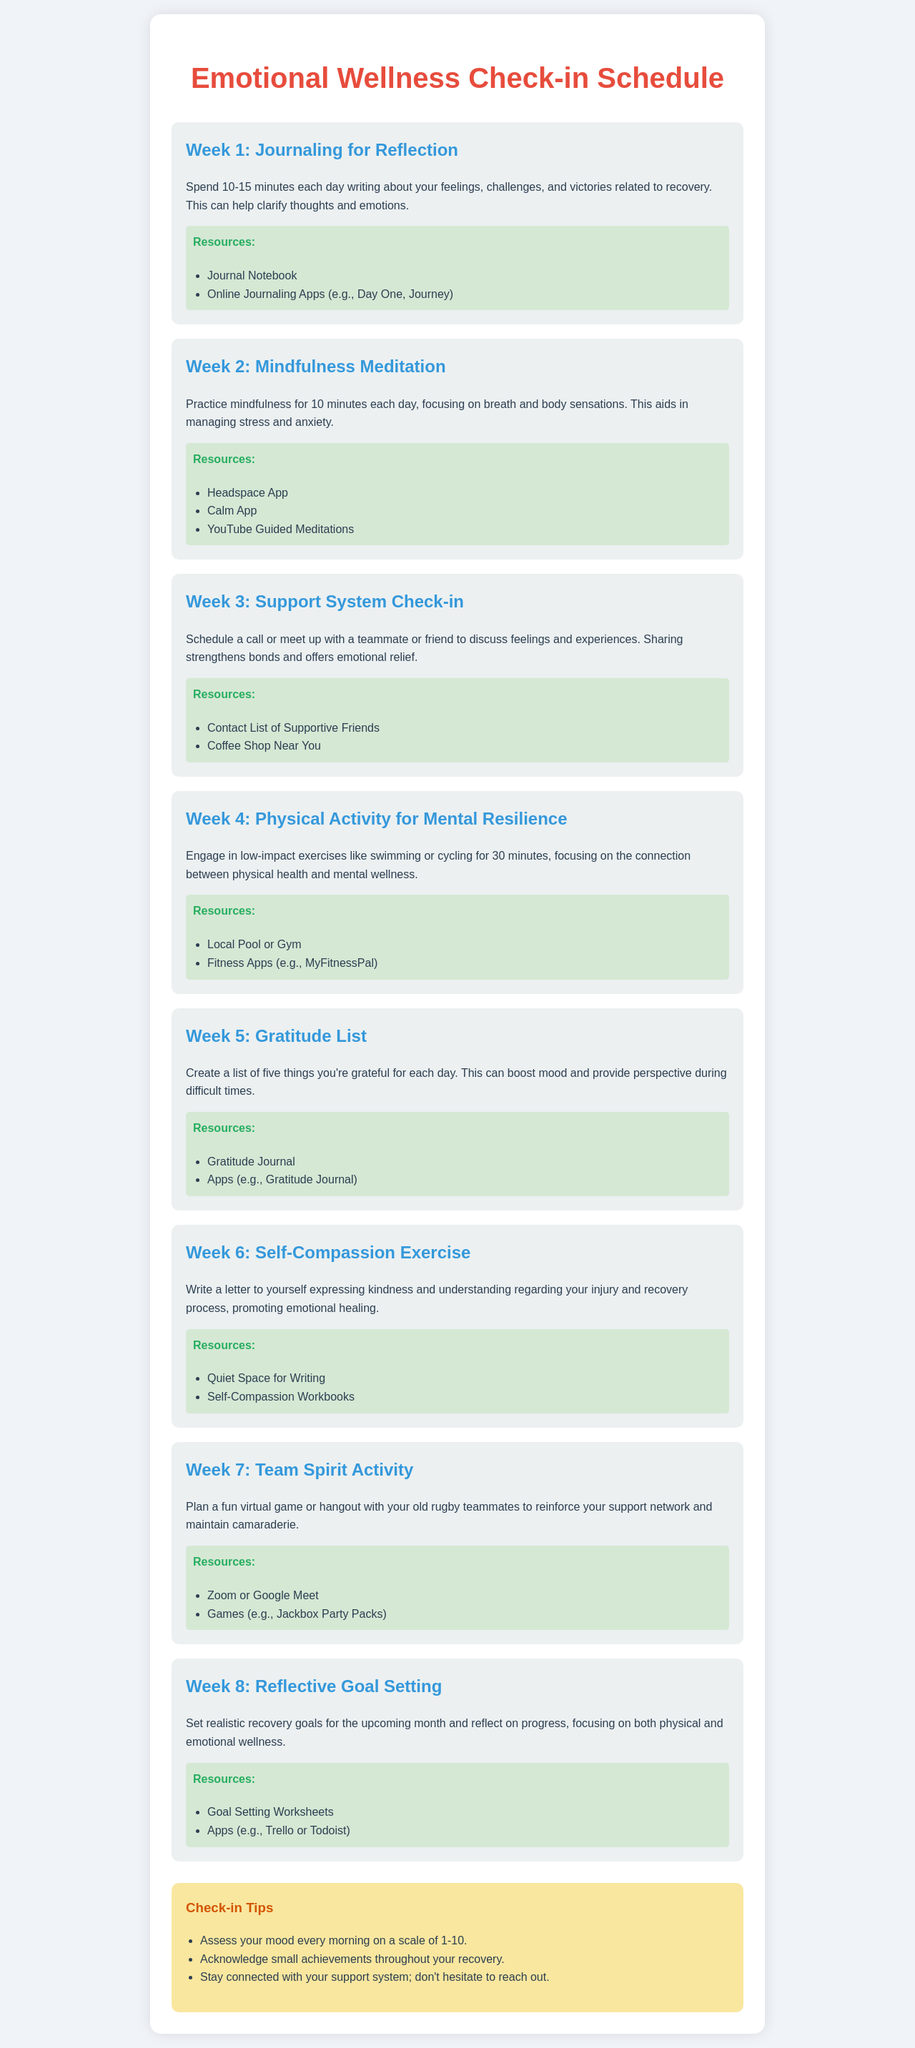what is the title of the document? The title can be found in the header of the document, which is "Emotional Wellness Check-in Schedule."
Answer: Emotional Wellness Check-in Schedule how many weeks are outlined in the schedule? The document lists a total of eight weeks for emotional wellness activities.
Answer: 8 what is the focus of Week 3's activity? Week 3's activity centers around having a support system check-in, allowing for sharing feelings and experiences.
Answer: Support System Check-in name one resource listed for Week 5. The document provides various resources for each week, such as "Gratitude Journal" for Week 5.
Answer: Gratitude Journal what type of exercise is suggested in Week 4? Week 4 recommends engaging in low-impact exercises to boost mental resilience, specifying activities like swimming or cycling.
Answer: Low-impact exercises which app is suggested for mindfulness meditation in Week 2? Week 2 suggests folosowing the practice of mindfulness meditation using the "Headspace App."
Answer: Headspace App what activity should be done for 10-15 minutes each day in Week 1? In Week 1, the suggested activity is journaling, focused on reflecting on feelings and experiences.
Answer: Journaling list one virtual platform mentioned for team spirit activities in Week 7. One of the platforms mentioned for virtual team spirit activities is "Zoom."
Answer: Zoom 